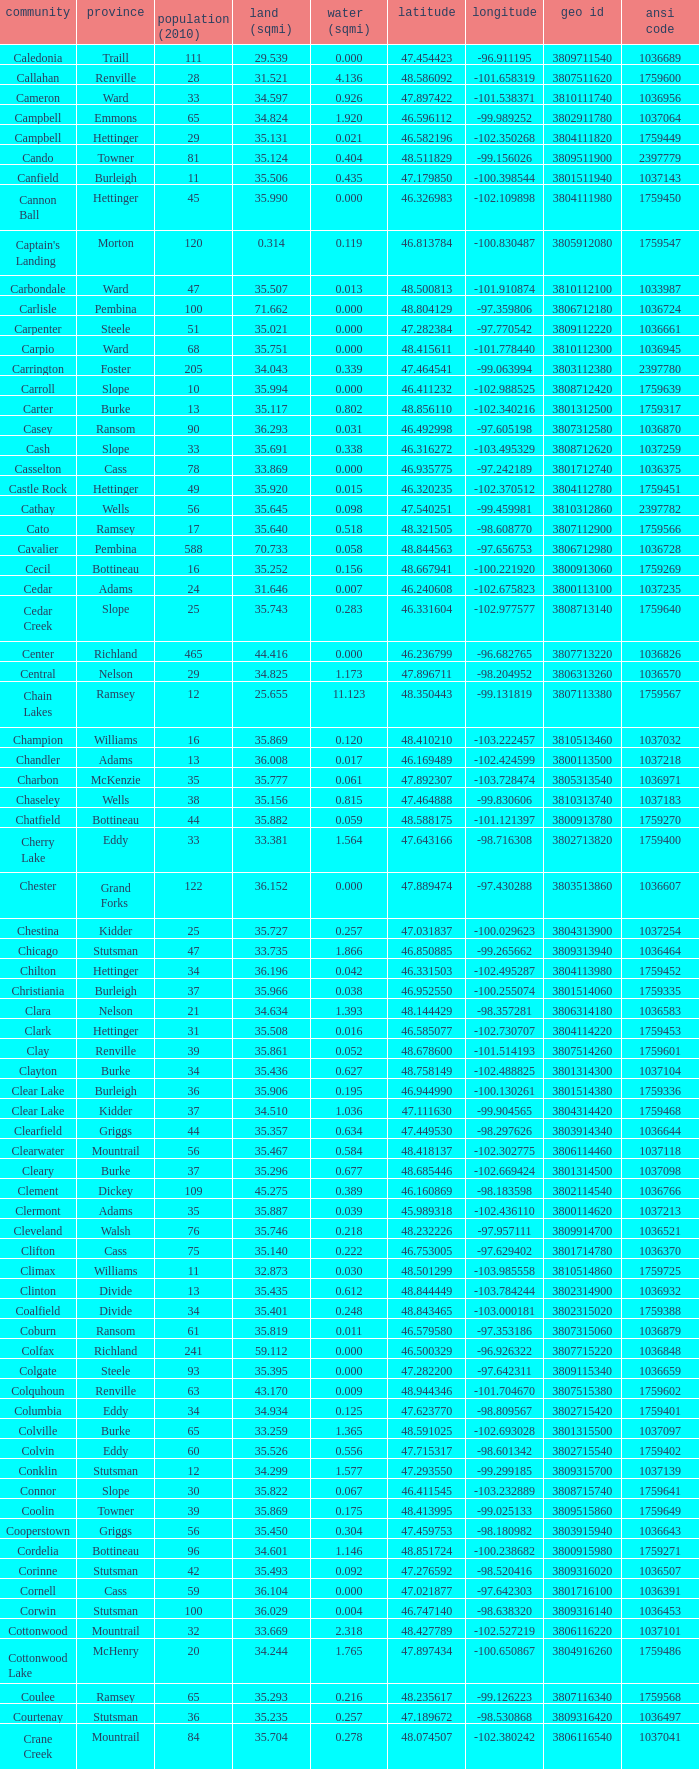What was the longitudinal coordinate of the township with a latitudinal value of 4 -98.857272. 